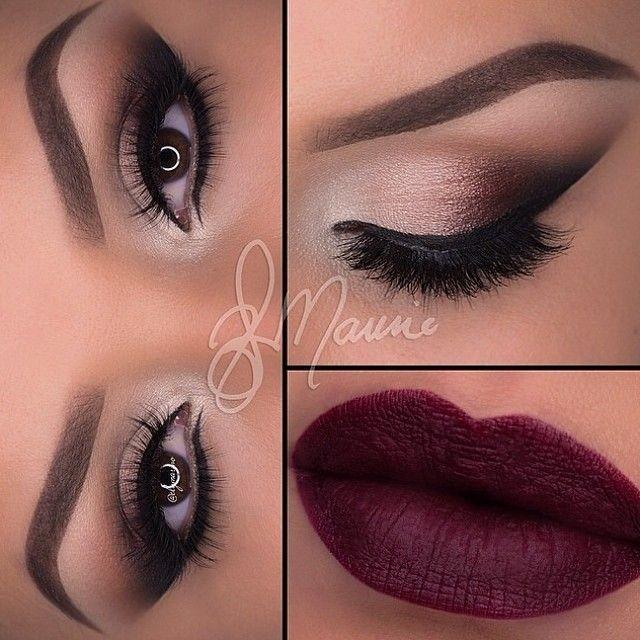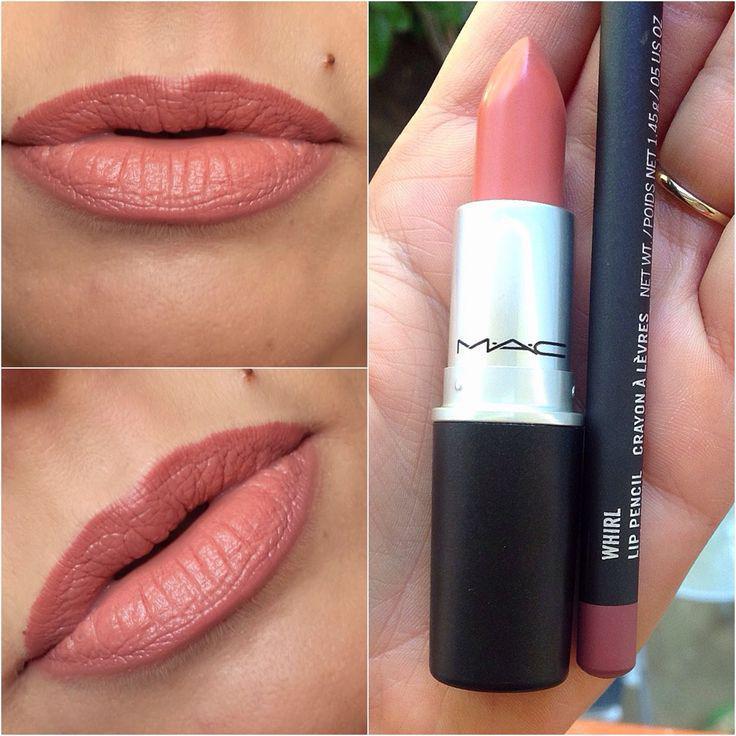The first image is the image on the left, the second image is the image on the right. Analyze the images presented: Is the assertion "Lip shapes are depicted in one or more images." valid? Answer yes or no. Yes. 